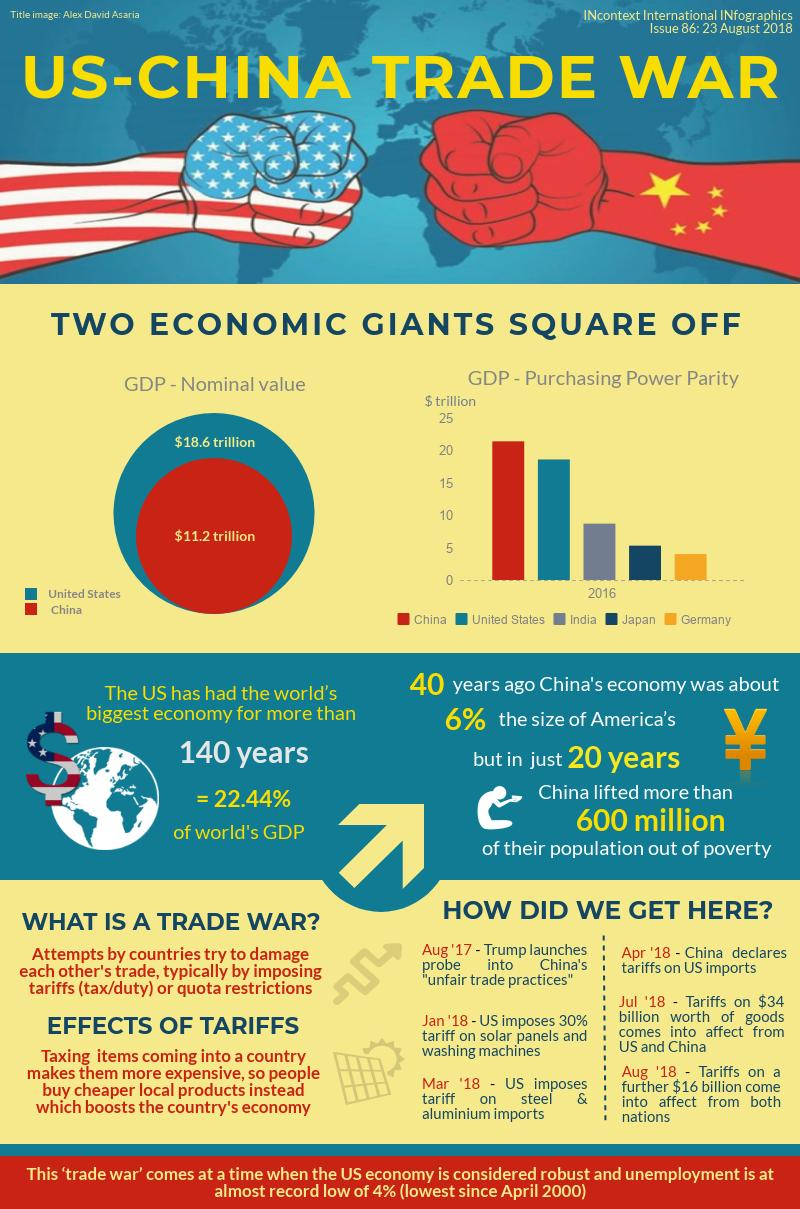Specify some key components in this picture. According to the Purchasing Power Parity GDP, China was the country with the highest economic output, surpassing all other nations in terms of buying power. The three countries with the highest PPP (purchasing power parity) GDP are China, the United States, and India, in descending order. The United States imposed tariffs on solar panels before steel. The nominal GDP of China is $11.2 trillion. China declared tariffs on US imports before Trump launched an investigation into China's unfair trade practices. 